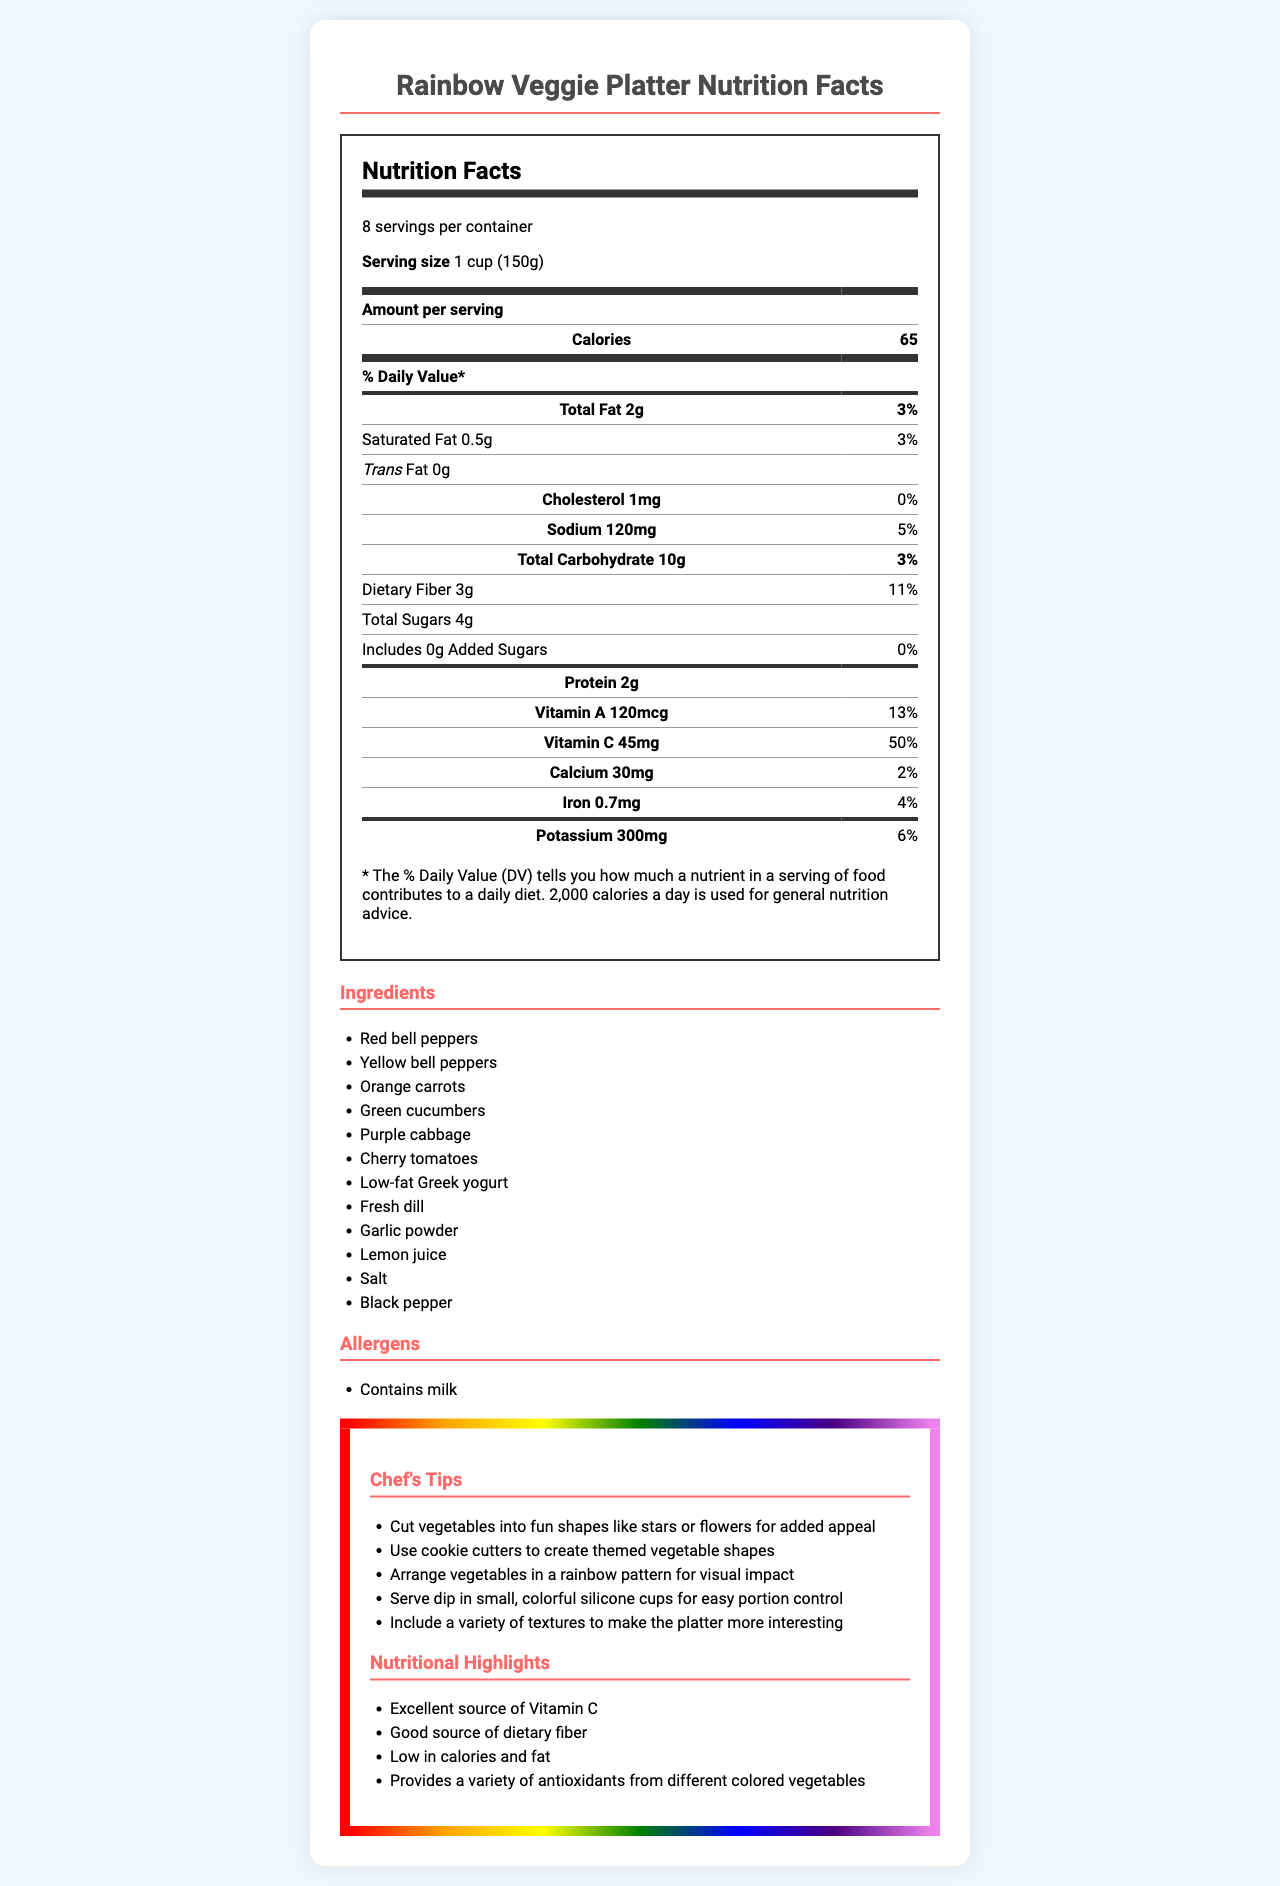What is the serving size for the vegetable platter? The serving size is clearly listed at the top as "Serving size: 1 cup (150g)".
Answer: 1 cup (150g) How many servings are in the container? The document states that there are "8 servings per container".
Answer: 8 How many calories are in one serving of the vegetable platter? Under the 'Amount per serving' section, it notes that each serving has 65 calories.
Answer: 65 calories What percentage of the daily value of Vitamin C does one serving provide? The nutrition facts list Vitamin C as 45mg per serving with a daily value of 50%.
Answer: 50% How much dietary fiber does one serving contain? The table lists the dietary fiber content as 3g per serving.
Answer: 3g What is the total amount of carbohydrates per serving? The document specifies the total carbohydrates per serving as 10g.
Answer: 10g Which of the following ingredients are not included in the vegetable platter? A. Green beans B. Red bell peppers C. Orange carrots D. Purple cabbage Green beans are not listed in the ingredients section, whereas red bell peppers, orange carrots, and purple cabbage are.
Answer: A. Green beans Which nutrient provides the highest daily value percentage per serving? I. Vitamin A II. Vitamin C III. Dietary Fiber IV. Iron Vitamin C has the highest daily value percentage at 50%, compared to Vitamin A (13%), Dietary Fiber (11%), and Iron (4%).
Answer: II. Vitamin C Does the vegetable platter contain added sugars? The document states "Includes 0g Added Sugars," indicating there are no added sugars.
Answer: No Are there any allergens to be aware of in this vegetable platter? The allergens section indicates that the platter contains milk.
Answer: Yes Summarize the main points of this document. The document includes an in-depth nutritional analysis along with practical tips for presenting the platter and the health benefits of its components.
Answer: This document provides the nutritional breakdown of a rainbow-themed veggie platter with low-fat dip, including details on serving size, calories, fats, carbohydrates, and vitamins. Additionally, it lists ingredients, highlights allergen information, offers chef's tips, and notes the nutritional benefits. What type of event is this vegetable platter designed for? The document does not provide information about the type of event; it only mentions that it is for a rainbow-themed classroom party, but not the specific occasion.
Answer: Not enough information What is the sodium content per serving? The sodium content is listed in the nutrition facts as 120mg per serving.
Answer: 120mg What are some chef's tips mentioned for presenting the vegetable platter? The document lists several tips under the "Chef's Tips" section for making the platter visually appealing and fun to eat.
Answer: Cut vegetables into fun shapes, use cookie cutters, arrange in a rainbow pattern, serve dip in small cups, include a variety of textures What is the total fat content per serving and what percentage of the daily value does it represent? The document lists the total fat content as 2g per serving and mentions that it represents 3% of the daily value.
Answer: 2g, 3% 